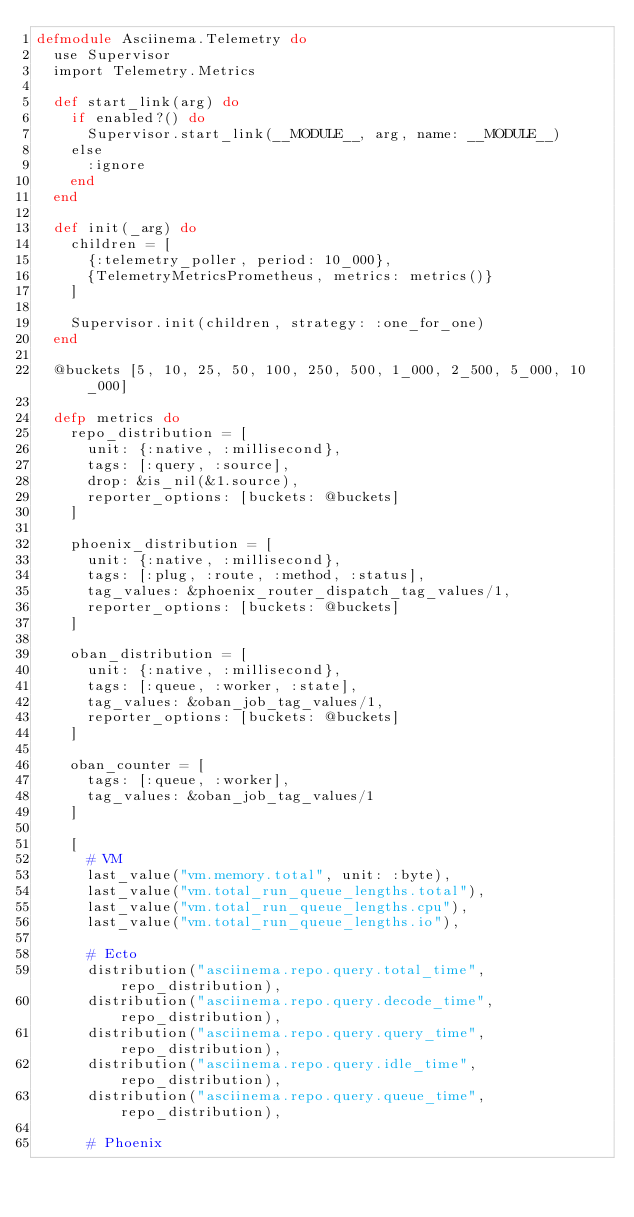<code> <loc_0><loc_0><loc_500><loc_500><_Elixir_>defmodule Asciinema.Telemetry do
  use Supervisor
  import Telemetry.Metrics

  def start_link(arg) do
    if enabled?() do
      Supervisor.start_link(__MODULE__, arg, name: __MODULE__)
    else
      :ignore
    end
  end

  def init(_arg) do
    children = [
      {:telemetry_poller, period: 10_000},
      {TelemetryMetricsPrometheus, metrics: metrics()}
    ]

    Supervisor.init(children, strategy: :one_for_one)
  end

  @buckets [5, 10, 25, 50, 100, 250, 500, 1_000, 2_500, 5_000, 10_000]

  defp metrics do
    repo_distribution = [
      unit: {:native, :millisecond},
      tags: [:query, :source],
      drop: &is_nil(&1.source),
      reporter_options: [buckets: @buckets]
    ]

    phoenix_distribution = [
      unit: {:native, :millisecond},
      tags: [:plug, :route, :method, :status],
      tag_values: &phoenix_router_dispatch_tag_values/1,
      reporter_options: [buckets: @buckets]
    ]

    oban_distribution = [
      unit: {:native, :millisecond},
      tags: [:queue, :worker, :state],
      tag_values: &oban_job_tag_values/1,
      reporter_options: [buckets: @buckets]
    ]

    oban_counter = [
      tags: [:queue, :worker],
      tag_values: &oban_job_tag_values/1
    ]

    [
      # VM
      last_value("vm.memory.total", unit: :byte),
      last_value("vm.total_run_queue_lengths.total"),
      last_value("vm.total_run_queue_lengths.cpu"),
      last_value("vm.total_run_queue_lengths.io"),

      # Ecto
      distribution("asciinema.repo.query.total_time", repo_distribution),
      distribution("asciinema.repo.query.decode_time", repo_distribution),
      distribution("asciinema.repo.query.query_time", repo_distribution),
      distribution("asciinema.repo.query.idle_time", repo_distribution),
      distribution("asciinema.repo.query.queue_time", repo_distribution),

      # Phoenix</code> 